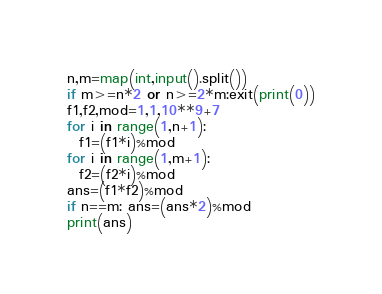Convert code to text. <code><loc_0><loc_0><loc_500><loc_500><_Python_>n,m=map(int,input().split())
if m>=n*2 or n>=2*m:exit(print(0))
f1,f2,mod=1,1,10**9+7
for i in range(1,n+1):
  f1=(f1*i)%mod
for i in range(1,m+1):
  f2=(f2*i)%mod
ans=(f1*f2)%mod
if n==m: ans=(ans*2)%mod
print(ans)</code> 